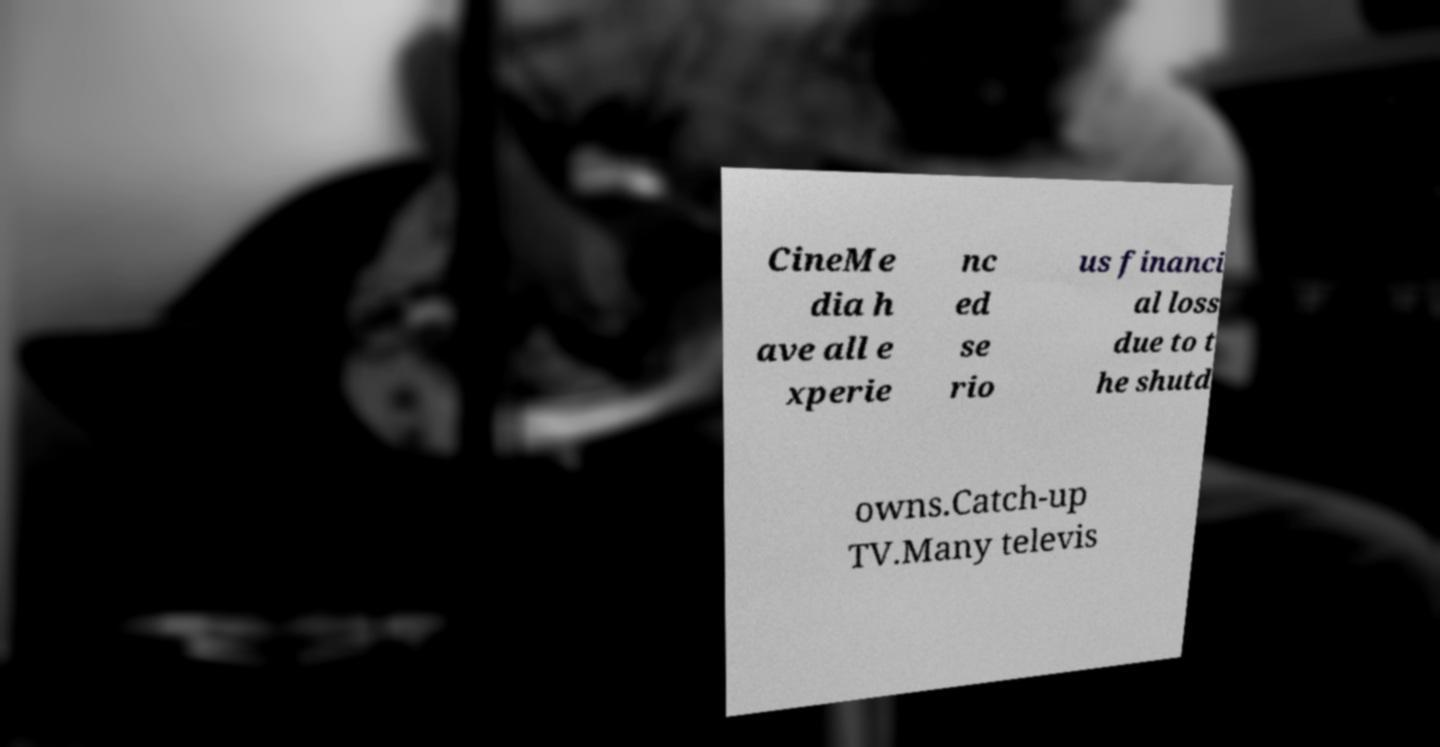What messages or text are displayed in this image? I need them in a readable, typed format. CineMe dia h ave all e xperie nc ed se rio us financi al loss due to t he shutd owns.Catch-up TV.Many televis 